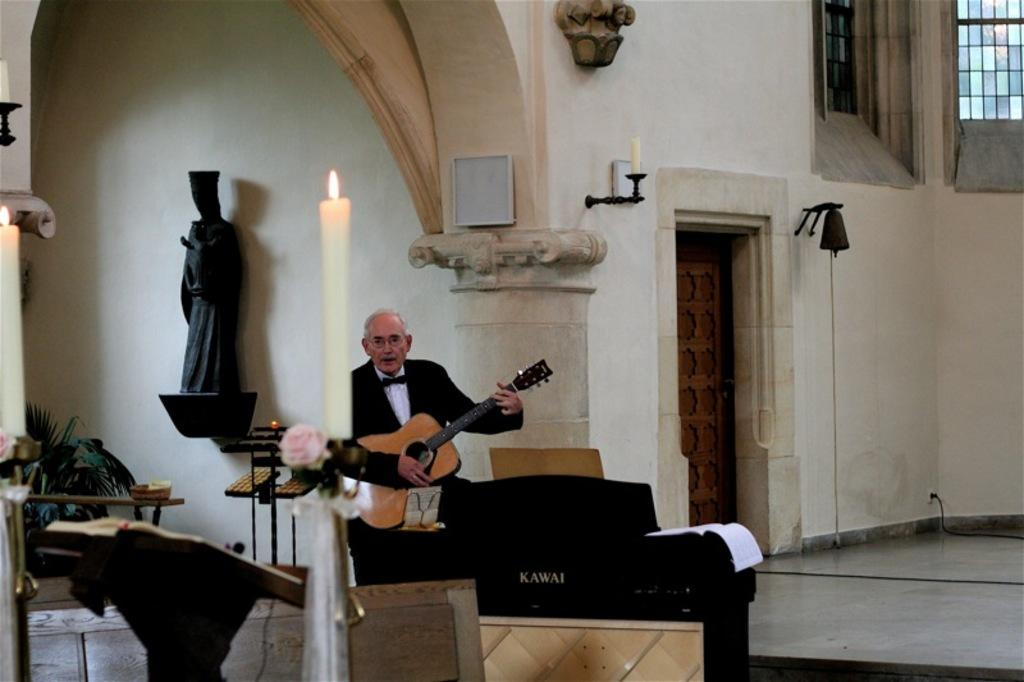What is the man in the image doing? The man is playing guitar in the image. What type of artwork can be seen in the image? There is a black sculpture in the image. What is the source of light in the image? There is a candle in the image. What type of vegetation is present in the image? There is a plant in the image. What type of object can be used for reading in the image? There is a book in the image. What architectural feature is present in the image? There is a door in the image. What type of soap is present in the image? There is no soap present in the image. What type of wall is visible in the image? There is no wall visible in the image. 